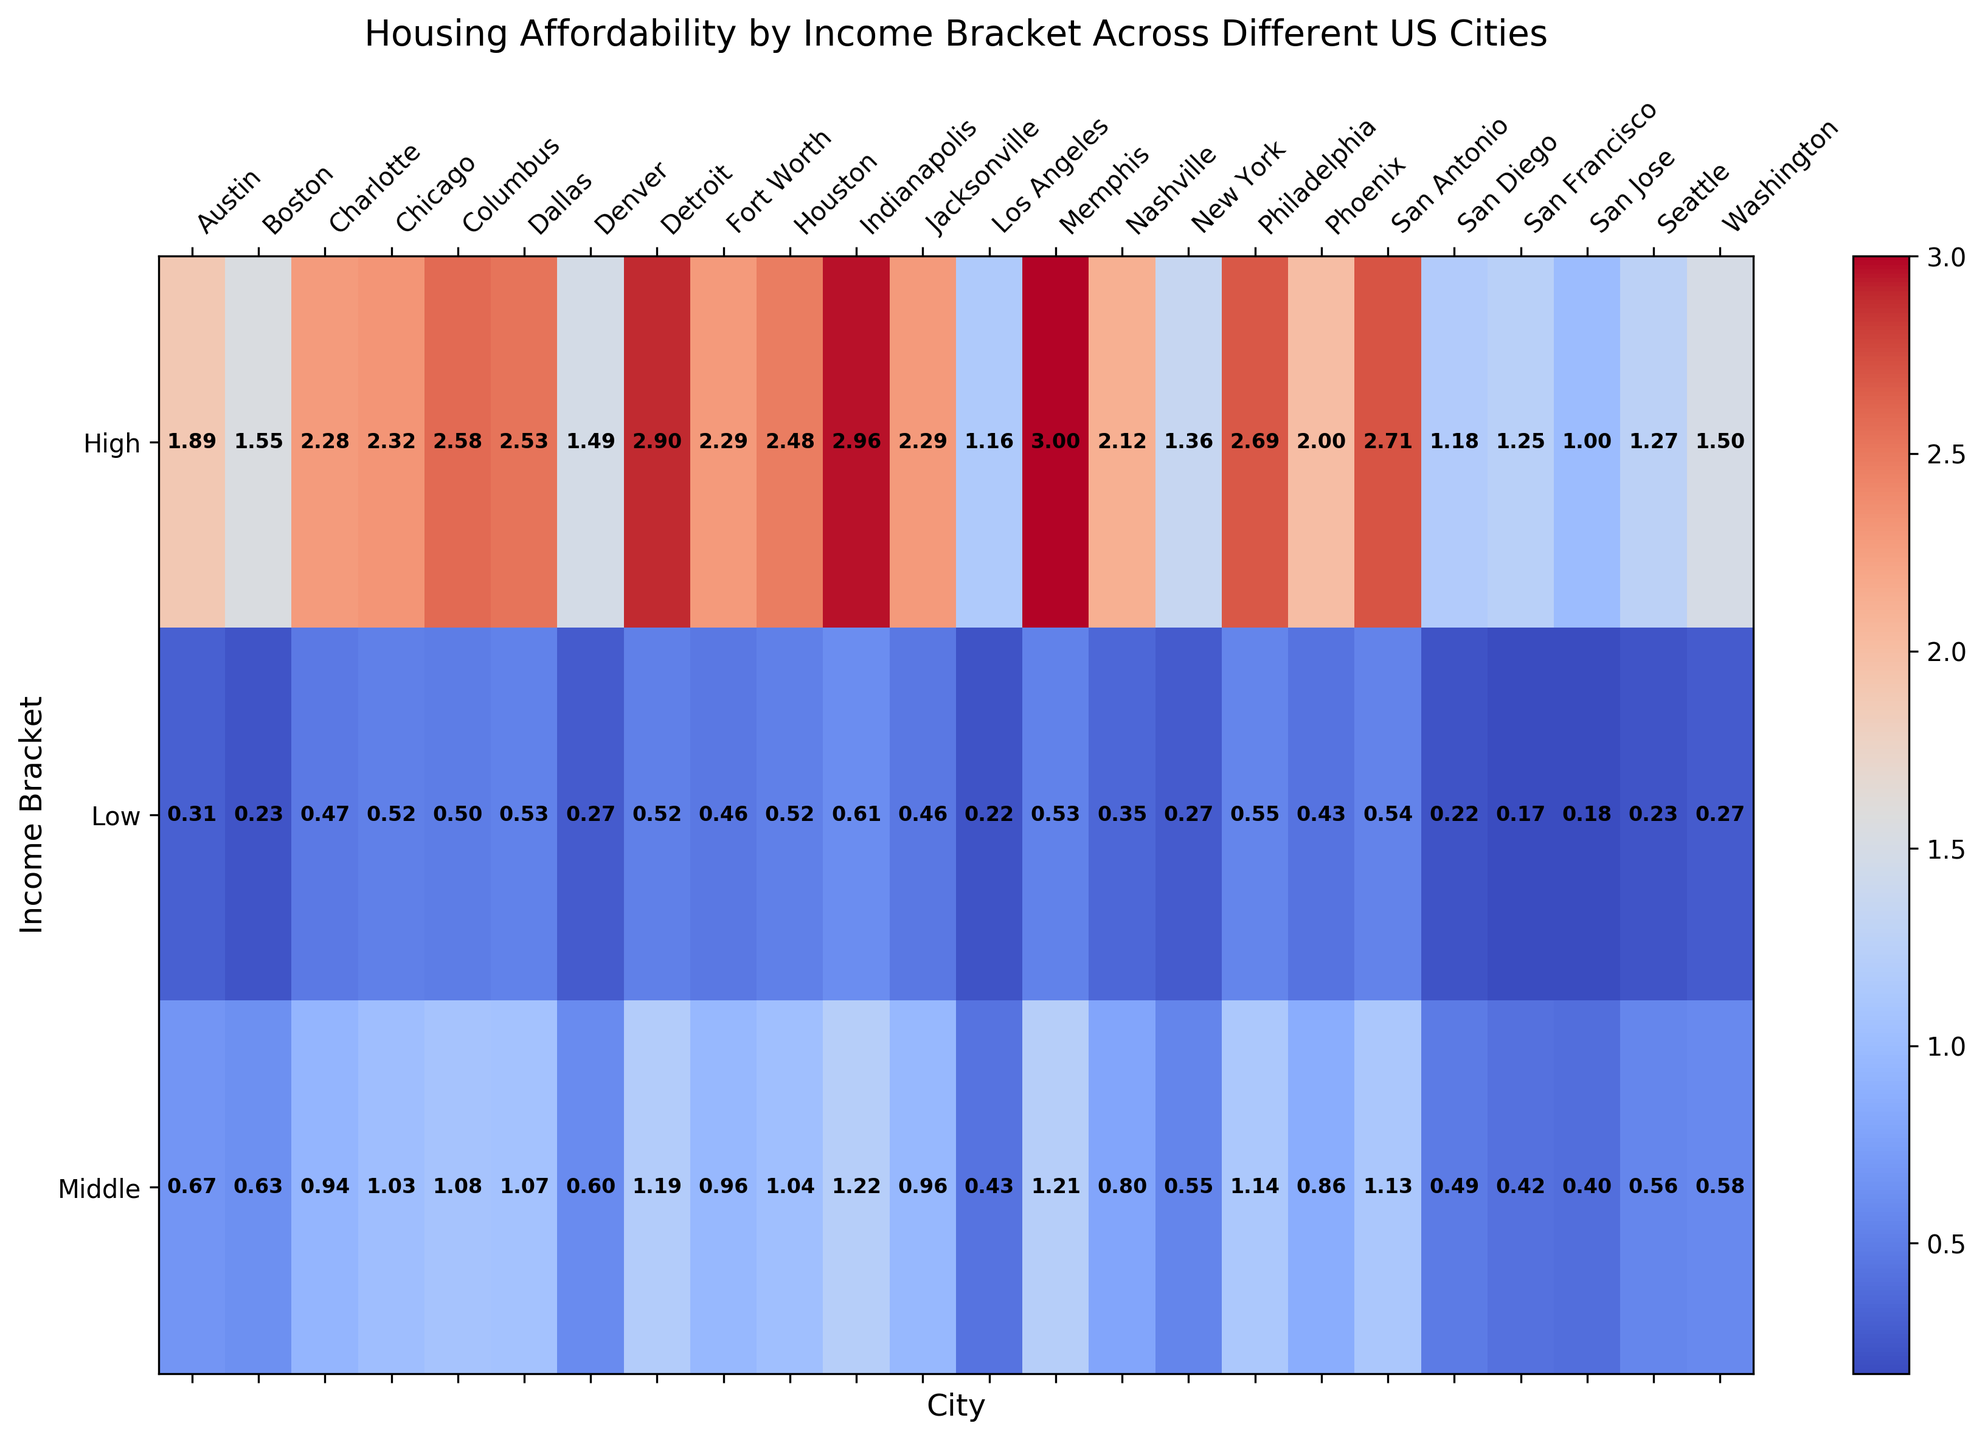1. Which city has the highest affordability index for high-income bracket? The color intensity and numerical value for the high-income bracket row will determine this. San Antonio has the darkest shade and highest value, 2.71, in the high-income bracket row.
Answer: San Antonio 2. What is the affordability index for middle-income bracket in San Francisco? Locate the middle-income bracket row for the city of San Francisco, which shows the value 0.42.
Answer: 0.42 3. Compare the affordability index between low income brackets in New York and Los Angeles. Which city is more affordable? Both indices will be found where their rows intersect with their corresponding cities; New York shows 0.27 while Los Angeles shows 0.22.
Answer: New York 4. Which income bracket and city combination has the lowest affordability index? By scanning the values, the lowest affordability index is for the low-income bracket in San Francisco with a value of 0.17.
Answer: Low-income bracket in San Francisco 5. What is the average affordability index for middle-income brackets across all cities? Sum all middle-income indices and divide by the total number of cities (New York: 0.55, Los Angeles: 0.43, Chicago: 1.03, Houston: 1.04, Phoenix: 0.86, Philadelphia: 1.14, San Antonio: 1.13, Dallas: 1.07, San Diego: 0.49, San Jose: 0.40, Austin: 0.67, Jacksonville: 0.96, Fort Worth: 0.96, Columbus: 1.08, Charlotte: 0.94, San Francisco: 0.42, Indianapolis: 1.22, Seattle: 0.56, Denver: 0.60, Washington: 0.58, Boston: 0.63, Detroit: 1.19, Nashville: 0.80, Memphis: 1.21). Total of 24 cities. Average = (0.55 + 0.43 + 1.03 + 1.04 + 0.86 + 1.14 + 1.13 + 1.07 + 0.49 + 0.40 + 0.67 + 0.96 + 0.96 + 1.08 + 0.94 + 0.42 + 1.22 + 0.56 + 0.60 + 0.58 + 0.63 + 1.19 + 0.80 + 1.21) / 24 = 0.861 repeated value.
Answer: 0.86 6. What is the difference in affordability index between high and low-income brackets in Houston? Subtract the low-income bracket index from the high-income bracket index for Houston: 2.48 - 0.52.
Answer: 1.96 7. How does Boston's affordability for high-income bracket compare to Washington's high-income bracket? Compare the values for the high-income brackets in both cities. Boston has 1.55, and Washington has 1.50, so Boston’s high-income affordability index is slightly higher.
Answer: Boston 8. Identify which income bracket for Phoenix has the closest affordability index to 1.00. The indices for Phoenix are 0.43 (low), 0.86 (middle), and 2.00 (high). The middle-income bracket's index of 0.86 is closest to 1.00.
Answer: Middle-income bracket 